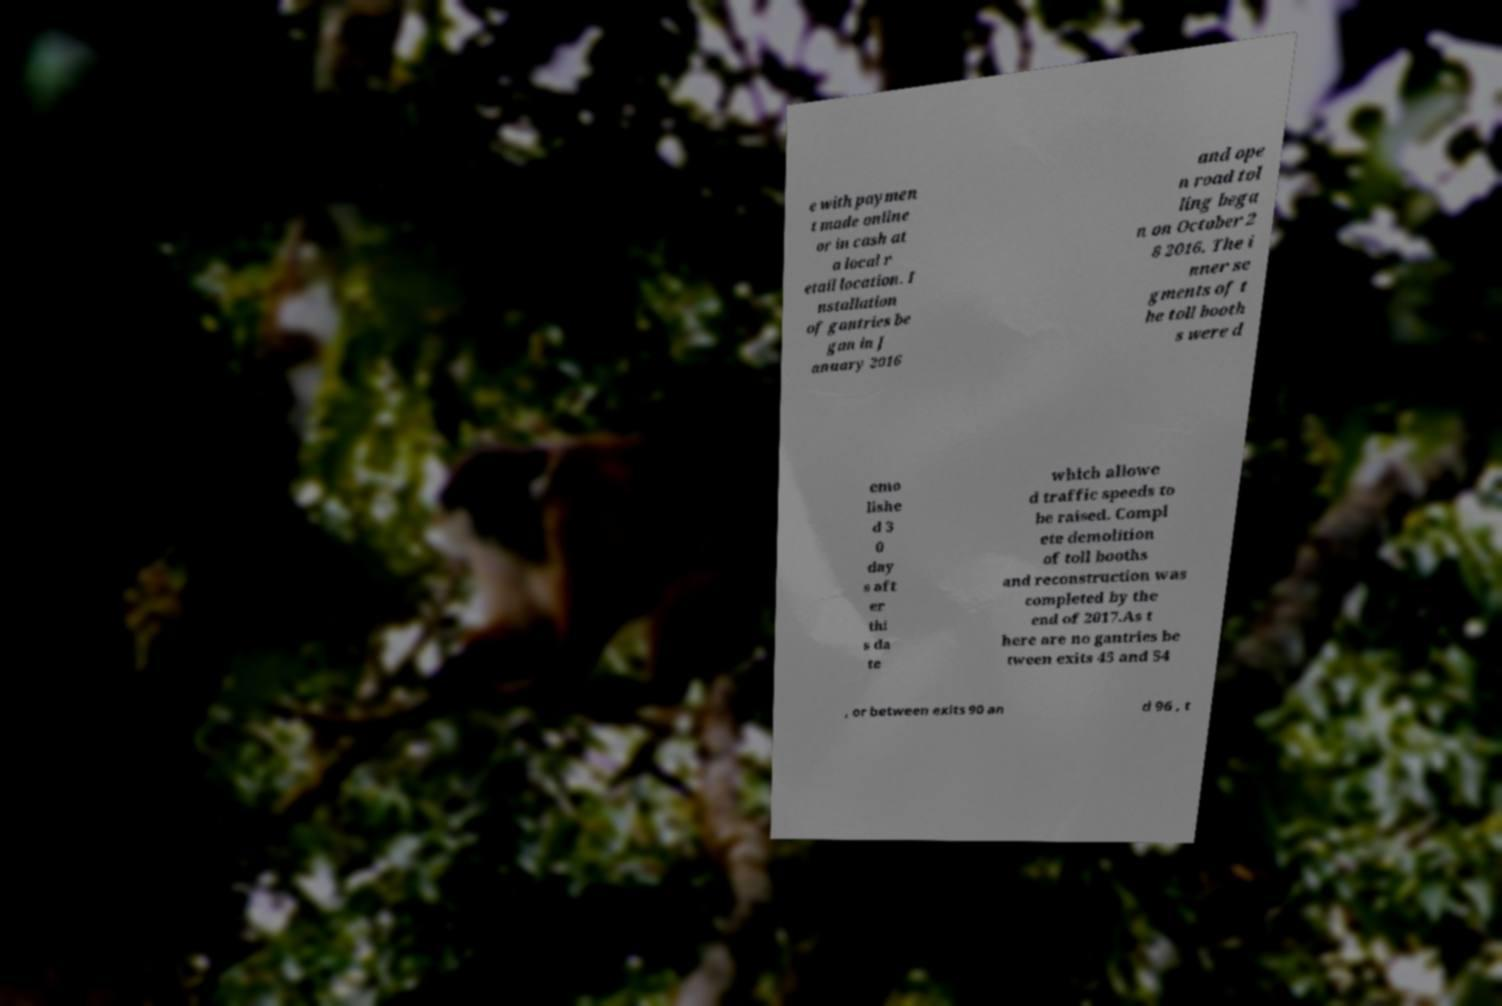Could you assist in decoding the text presented in this image and type it out clearly? e with paymen t made online or in cash at a local r etail location. I nstallation of gantries be gan in J anuary 2016 and ope n road tol ling bega n on October 2 8 2016. The i nner se gments of t he toll booth s were d emo lishe d 3 0 day s aft er thi s da te which allowe d traffic speeds to be raised. Compl ete demolition of toll booths and reconstruction was completed by the end of 2017.As t here are no gantries be tween exits 45 and 54 , or between exits 90 an d 96 , t 